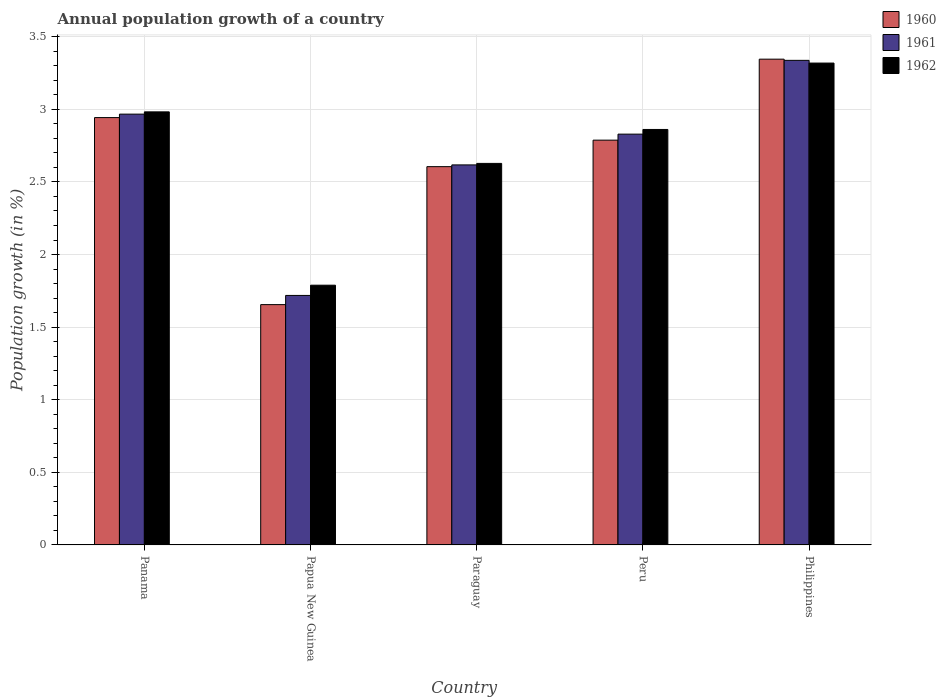How many different coloured bars are there?
Make the answer very short. 3. Are the number of bars per tick equal to the number of legend labels?
Provide a short and direct response. Yes. Are the number of bars on each tick of the X-axis equal?
Provide a succinct answer. Yes. How many bars are there on the 5th tick from the right?
Your answer should be very brief. 3. What is the label of the 4th group of bars from the left?
Provide a succinct answer. Peru. In how many cases, is the number of bars for a given country not equal to the number of legend labels?
Your answer should be very brief. 0. What is the annual population growth in 1962 in Panama?
Make the answer very short. 2.98. Across all countries, what is the maximum annual population growth in 1960?
Ensure brevity in your answer.  3.35. Across all countries, what is the minimum annual population growth in 1962?
Keep it short and to the point. 1.79. In which country was the annual population growth in 1960 minimum?
Provide a succinct answer. Papua New Guinea. What is the total annual population growth in 1960 in the graph?
Make the answer very short. 13.34. What is the difference between the annual population growth in 1962 in Papua New Guinea and that in Peru?
Keep it short and to the point. -1.07. What is the difference between the annual population growth in 1962 in Philippines and the annual population growth in 1960 in Peru?
Keep it short and to the point. 0.53. What is the average annual population growth in 1960 per country?
Provide a succinct answer. 2.67. What is the difference between the annual population growth of/in 1962 and annual population growth of/in 1960 in Philippines?
Offer a terse response. -0.03. What is the ratio of the annual population growth in 1960 in Panama to that in Papua New Guinea?
Your response must be concise. 1.78. Is the annual population growth in 1960 in Papua New Guinea less than that in Philippines?
Provide a succinct answer. Yes. Is the difference between the annual population growth in 1962 in Panama and Peru greater than the difference between the annual population growth in 1960 in Panama and Peru?
Provide a succinct answer. No. What is the difference between the highest and the second highest annual population growth in 1962?
Provide a short and direct response. -0.34. What is the difference between the highest and the lowest annual population growth in 1961?
Ensure brevity in your answer.  1.62. Is the sum of the annual population growth in 1962 in Papua New Guinea and Paraguay greater than the maximum annual population growth in 1960 across all countries?
Provide a succinct answer. Yes. Is it the case that in every country, the sum of the annual population growth in 1960 and annual population growth in 1962 is greater than the annual population growth in 1961?
Your response must be concise. Yes. What is the difference between two consecutive major ticks on the Y-axis?
Offer a terse response. 0.5. Are the values on the major ticks of Y-axis written in scientific E-notation?
Offer a very short reply. No. Does the graph contain grids?
Offer a very short reply. Yes. How are the legend labels stacked?
Your response must be concise. Vertical. What is the title of the graph?
Keep it short and to the point. Annual population growth of a country. Does "1960" appear as one of the legend labels in the graph?
Your answer should be compact. Yes. What is the label or title of the Y-axis?
Your answer should be very brief. Population growth (in %). What is the Population growth (in %) in 1960 in Panama?
Ensure brevity in your answer.  2.94. What is the Population growth (in %) in 1961 in Panama?
Your answer should be very brief. 2.97. What is the Population growth (in %) in 1962 in Panama?
Your answer should be compact. 2.98. What is the Population growth (in %) in 1960 in Papua New Guinea?
Ensure brevity in your answer.  1.66. What is the Population growth (in %) in 1961 in Papua New Guinea?
Provide a succinct answer. 1.72. What is the Population growth (in %) of 1962 in Papua New Guinea?
Provide a succinct answer. 1.79. What is the Population growth (in %) in 1960 in Paraguay?
Provide a succinct answer. 2.61. What is the Population growth (in %) of 1961 in Paraguay?
Provide a succinct answer. 2.62. What is the Population growth (in %) of 1962 in Paraguay?
Keep it short and to the point. 2.63. What is the Population growth (in %) in 1960 in Peru?
Ensure brevity in your answer.  2.79. What is the Population growth (in %) in 1961 in Peru?
Provide a short and direct response. 2.83. What is the Population growth (in %) in 1962 in Peru?
Keep it short and to the point. 2.86. What is the Population growth (in %) of 1960 in Philippines?
Ensure brevity in your answer.  3.35. What is the Population growth (in %) in 1961 in Philippines?
Give a very brief answer. 3.34. What is the Population growth (in %) in 1962 in Philippines?
Your answer should be compact. 3.32. Across all countries, what is the maximum Population growth (in %) of 1960?
Ensure brevity in your answer.  3.35. Across all countries, what is the maximum Population growth (in %) in 1961?
Provide a short and direct response. 3.34. Across all countries, what is the maximum Population growth (in %) of 1962?
Provide a succinct answer. 3.32. Across all countries, what is the minimum Population growth (in %) of 1960?
Provide a succinct answer. 1.66. Across all countries, what is the minimum Population growth (in %) of 1961?
Your response must be concise. 1.72. Across all countries, what is the minimum Population growth (in %) in 1962?
Offer a terse response. 1.79. What is the total Population growth (in %) of 1960 in the graph?
Your answer should be very brief. 13.34. What is the total Population growth (in %) in 1961 in the graph?
Make the answer very short. 13.47. What is the total Population growth (in %) of 1962 in the graph?
Ensure brevity in your answer.  13.58. What is the difference between the Population growth (in %) in 1960 in Panama and that in Papua New Guinea?
Your response must be concise. 1.29. What is the difference between the Population growth (in %) of 1961 in Panama and that in Papua New Guinea?
Make the answer very short. 1.25. What is the difference between the Population growth (in %) of 1962 in Panama and that in Papua New Guinea?
Your response must be concise. 1.19. What is the difference between the Population growth (in %) in 1960 in Panama and that in Paraguay?
Provide a succinct answer. 0.34. What is the difference between the Population growth (in %) of 1961 in Panama and that in Paraguay?
Your answer should be very brief. 0.35. What is the difference between the Population growth (in %) in 1962 in Panama and that in Paraguay?
Provide a short and direct response. 0.35. What is the difference between the Population growth (in %) of 1960 in Panama and that in Peru?
Keep it short and to the point. 0.16. What is the difference between the Population growth (in %) of 1961 in Panama and that in Peru?
Your answer should be compact. 0.14. What is the difference between the Population growth (in %) of 1962 in Panama and that in Peru?
Offer a terse response. 0.12. What is the difference between the Population growth (in %) of 1960 in Panama and that in Philippines?
Offer a terse response. -0.4. What is the difference between the Population growth (in %) in 1961 in Panama and that in Philippines?
Give a very brief answer. -0.37. What is the difference between the Population growth (in %) of 1962 in Panama and that in Philippines?
Provide a short and direct response. -0.34. What is the difference between the Population growth (in %) in 1960 in Papua New Guinea and that in Paraguay?
Provide a short and direct response. -0.95. What is the difference between the Population growth (in %) of 1961 in Papua New Guinea and that in Paraguay?
Your answer should be compact. -0.9. What is the difference between the Population growth (in %) of 1962 in Papua New Guinea and that in Paraguay?
Provide a succinct answer. -0.84. What is the difference between the Population growth (in %) of 1960 in Papua New Guinea and that in Peru?
Your answer should be compact. -1.13. What is the difference between the Population growth (in %) in 1961 in Papua New Guinea and that in Peru?
Your answer should be very brief. -1.11. What is the difference between the Population growth (in %) in 1962 in Papua New Guinea and that in Peru?
Provide a succinct answer. -1.07. What is the difference between the Population growth (in %) of 1960 in Papua New Guinea and that in Philippines?
Offer a very short reply. -1.69. What is the difference between the Population growth (in %) in 1961 in Papua New Guinea and that in Philippines?
Keep it short and to the point. -1.62. What is the difference between the Population growth (in %) of 1962 in Papua New Guinea and that in Philippines?
Your response must be concise. -1.53. What is the difference between the Population growth (in %) of 1960 in Paraguay and that in Peru?
Your response must be concise. -0.18. What is the difference between the Population growth (in %) of 1961 in Paraguay and that in Peru?
Provide a short and direct response. -0.21. What is the difference between the Population growth (in %) in 1962 in Paraguay and that in Peru?
Offer a very short reply. -0.23. What is the difference between the Population growth (in %) in 1960 in Paraguay and that in Philippines?
Provide a short and direct response. -0.74. What is the difference between the Population growth (in %) of 1961 in Paraguay and that in Philippines?
Ensure brevity in your answer.  -0.72. What is the difference between the Population growth (in %) in 1962 in Paraguay and that in Philippines?
Provide a short and direct response. -0.69. What is the difference between the Population growth (in %) in 1960 in Peru and that in Philippines?
Make the answer very short. -0.56. What is the difference between the Population growth (in %) of 1961 in Peru and that in Philippines?
Ensure brevity in your answer.  -0.51. What is the difference between the Population growth (in %) of 1962 in Peru and that in Philippines?
Your answer should be very brief. -0.46. What is the difference between the Population growth (in %) of 1960 in Panama and the Population growth (in %) of 1961 in Papua New Guinea?
Make the answer very short. 1.22. What is the difference between the Population growth (in %) in 1960 in Panama and the Population growth (in %) in 1962 in Papua New Guinea?
Provide a short and direct response. 1.15. What is the difference between the Population growth (in %) of 1961 in Panama and the Population growth (in %) of 1962 in Papua New Guinea?
Provide a succinct answer. 1.18. What is the difference between the Population growth (in %) in 1960 in Panama and the Population growth (in %) in 1961 in Paraguay?
Ensure brevity in your answer.  0.33. What is the difference between the Population growth (in %) of 1960 in Panama and the Population growth (in %) of 1962 in Paraguay?
Provide a short and direct response. 0.32. What is the difference between the Population growth (in %) of 1961 in Panama and the Population growth (in %) of 1962 in Paraguay?
Ensure brevity in your answer.  0.34. What is the difference between the Population growth (in %) in 1960 in Panama and the Population growth (in %) in 1961 in Peru?
Your answer should be compact. 0.11. What is the difference between the Population growth (in %) of 1960 in Panama and the Population growth (in %) of 1962 in Peru?
Ensure brevity in your answer.  0.08. What is the difference between the Population growth (in %) in 1961 in Panama and the Population growth (in %) in 1962 in Peru?
Your response must be concise. 0.11. What is the difference between the Population growth (in %) in 1960 in Panama and the Population growth (in %) in 1961 in Philippines?
Make the answer very short. -0.39. What is the difference between the Population growth (in %) in 1960 in Panama and the Population growth (in %) in 1962 in Philippines?
Provide a short and direct response. -0.38. What is the difference between the Population growth (in %) of 1961 in Panama and the Population growth (in %) of 1962 in Philippines?
Provide a short and direct response. -0.35. What is the difference between the Population growth (in %) in 1960 in Papua New Guinea and the Population growth (in %) in 1961 in Paraguay?
Give a very brief answer. -0.96. What is the difference between the Population growth (in %) of 1960 in Papua New Guinea and the Population growth (in %) of 1962 in Paraguay?
Keep it short and to the point. -0.97. What is the difference between the Population growth (in %) in 1961 in Papua New Guinea and the Population growth (in %) in 1962 in Paraguay?
Provide a short and direct response. -0.91. What is the difference between the Population growth (in %) in 1960 in Papua New Guinea and the Population growth (in %) in 1961 in Peru?
Keep it short and to the point. -1.17. What is the difference between the Population growth (in %) of 1960 in Papua New Guinea and the Population growth (in %) of 1962 in Peru?
Make the answer very short. -1.21. What is the difference between the Population growth (in %) in 1961 in Papua New Guinea and the Population growth (in %) in 1962 in Peru?
Make the answer very short. -1.14. What is the difference between the Population growth (in %) in 1960 in Papua New Guinea and the Population growth (in %) in 1961 in Philippines?
Your answer should be compact. -1.68. What is the difference between the Population growth (in %) in 1960 in Papua New Guinea and the Population growth (in %) in 1962 in Philippines?
Your answer should be very brief. -1.66. What is the difference between the Population growth (in %) in 1961 in Papua New Guinea and the Population growth (in %) in 1962 in Philippines?
Provide a succinct answer. -1.6. What is the difference between the Population growth (in %) of 1960 in Paraguay and the Population growth (in %) of 1961 in Peru?
Your answer should be very brief. -0.22. What is the difference between the Population growth (in %) in 1960 in Paraguay and the Population growth (in %) in 1962 in Peru?
Make the answer very short. -0.26. What is the difference between the Population growth (in %) in 1961 in Paraguay and the Population growth (in %) in 1962 in Peru?
Offer a terse response. -0.24. What is the difference between the Population growth (in %) in 1960 in Paraguay and the Population growth (in %) in 1961 in Philippines?
Your response must be concise. -0.73. What is the difference between the Population growth (in %) of 1960 in Paraguay and the Population growth (in %) of 1962 in Philippines?
Provide a short and direct response. -0.71. What is the difference between the Population growth (in %) in 1961 in Paraguay and the Population growth (in %) in 1962 in Philippines?
Provide a short and direct response. -0.7. What is the difference between the Population growth (in %) in 1960 in Peru and the Population growth (in %) in 1961 in Philippines?
Provide a succinct answer. -0.55. What is the difference between the Population growth (in %) of 1960 in Peru and the Population growth (in %) of 1962 in Philippines?
Your answer should be very brief. -0.53. What is the difference between the Population growth (in %) of 1961 in Peru and the Population growth (in %) of 1962 in Philippines?
Your answer should be compact. -0.49. What is the average Population growth (in %) of 1960 per country?
Offer a very short reply. 2.67. What is the average Population growth (in %) in 1961 per country?
Provide a short and direct response. 2.69. What is the average Population growth (in %) of 1962 per country?
Your answer should be compact. 2.72. What is the difference between the Population growth (in %) in 1960 and Population growth (in %) in 1961 in Panama?
Your answer should be very brief. -0.02. What is the difference between the Population growth (in %) in 1960 and Population growth (in %) in 1962 in Panama?
Provide a succinct answer. -0.04. What is the difference between the Population growth (in %) of 1961 and Population growth (in %) of 1962 in Panama?
Ensure brevity in your answer.  -0.02. What is the difference between the Population growth (in %) of 1960 and Population growth (in %) of 1961 in Papua New Guinea?
Ensure brevity in your answer.  -0.06. What is the difference between the Population growth (in %) of 1960 and Population growth (in %) of 1962 in Papua New Guinea?
Your response must be concise. -0.13. What is the difference between the Population growth (in %) in 1961 and Population growth (in %) in 1962 in Papua New Guinea?
Offer a very short reply. -0.07. What is the difference between the Population growth (in %) in 1960 and Population growth (in %) in 1961 in Paraguay?
Offer a terse response. -0.01. What is the difference between the Population growth (in %) of 1960 and Population growth (in %) of 1962 in Paraguay?
Your response must be concise. -0.02. What is the difference between the Population growth (in %) in 1961 and Population growth (in %) in 1962 in Paraguay?
Your response must be concise. -0.01. What is the difference between the Population growth (in %) of 1960 and Population growth (in %) of 1961 in Peru?
Your answer should be compact. -0.04. What is the difference between the Population growth (in %) of 1960 and Population growth (in %) of 1962 in Peru?
Your answer should be compact. -0.07. What is the difference between the Population growth (in %) of 1961 and Population growth (in %) of 1962 in Peru?
Your answer should be very brief. -0.03. What is the difference between the Population growth (in %) in 1960 and Population growth (in %) in 1961 in Philippines?
Keep it short and to the point. 0.01. What is the difference between the Population growth (in %) of 1960 and Population growth (in %) of 1962 in Philippines?
Provide a short and direct response. 0.03. What is the difference between the Population growth (in %) of 1961 and Population growth (in %) of 1962 in Philippines?
Keep it short and to the point. 0.02. What is the ratio of the Population growth (in %) in 1960 in Panama to that in Papua New Guinea?
Your response must be concise. 1.78. What is the ratio of the Population growth (in %) in 1961 in Panama to that in Papua New Guinea?
Provide a short and direct response. 1.73. What is the ratio of the Population growth (in %) in 1962 in Panama to that in Papua New Guinea?
Your answer should be compact. 1.67. What is the ratio of the Population growth (in %) of 1960 in Panama to that in Paraguay?
Ensure brevity in your answer.  1.13. What is the ratio of the Population growth (in %) of 1961 in Panama to that in Paraguay?
Offer a very short reply. 1.13. What is the ratio of the Population growth (in %) in 1962 in Panama to that in Paraguay?
Provide a short and direct response. 1.14. What is the ratio of the Population growth (in %) in 1960 in Panama to that in Peru?
Your answer should be compact. 1.06. What is the ratio of the Population growth (in %) of 1961 in Panama to that in Peru?
Your response must be concise. 1.05. What is the ratio of the Population growth (in %) of 1962 in Panama to that in Peru?
Offer a very short reply. 1.04. What is the ratio of the Population growth (in %) in 1960 in Panama to that in Philippines?
Give a very brief answer. 0.88. What is the ratio of the Population growth (in %) in 1961 in Panama to that in Philippines?
Keep it short and to the point. 0.89. What is the ratio of the Population growth (in %) in 1962 in Panama to that in Philippines?
Ensure brevity in your answer.  0.9. What is the ratio of the Population growth (in %) of 1960 in Papua New Guinea to that in Paraguay?
Your answer should be compact. 0.64. What is the ratio of the Population growth (in %) of 1961 in Papua New Guinea to that in Paraguay?
Ensure brevity in your answer.  0.66. What is the ratio of the Population growth (in %) of 1962 in Papua New Guinea to that in Paraguay?
Your answer should be compact. 0.68. What is the ratio of the Population growth (in %) in 1960 in Papua New Guinea to that in Peru?
Give a very brief answer. 0.59. What is the ratio of the Population growth (in %) of 1961 in Papua New Guinea to that in Peru?
Ensure brevity in your answer.  0.61. What is the ratio of the Population growth (in %) in 1962 in Papua New Guinea to that in Peru?
Offer a terse response. 0.63. What is the ratio of the Population growth (in %) in 1960 in Papua New Guinea to that in Philippines?
Ensure brevity in your answer.  0.49. What is the ratio of the Population growth (in %) of 1961 in Papua New Guinea to that in Philippines?
Provide a short and direct response. 0.51. What is the ratio of the Population growth (in %) of 1962 in Papua New Guinea to that in Philippines?
Provide a short and direct response. 0.54. What is the ratio of the Population growth (in %) of 1960 in Paraguay to that in Peru?
Offer a very short reply. 0.93. What is the ratio of the Population growth (in %) of 1961 in Paraguay to that in Peru?
Provide a succinct answer. 0.93. What is the ratio of the Population growth (in %) of 1962 in Paraguay to that in Peru?
Provide a short and direct response. 0.92. What is the ratio of the Population growth (in %) in 1960 in Paraguay to that in Philippines?
Make the answer very short. 0.78. What is the ratio of the Population growth (in %) of 1961 in Paraguay to that in Philippines?
Offer a very short reply. 0.78. What is the ratio of the Population growth (in %) in 1962 in Paraguay to that in Philippines?
Make the answer very short. 0.79. What is the ratio of the Population growth (in %) of 1960 in Peru to that in Philippines?
Ensure brevity in your answer.  0.83. What is the ratio of the Population growth (in %) in 1961 in Peru to that in Philippines?
Your answer should be very brief. 0.85. What is the ratio of the Population growth (in %) of 1962 in Peru to that in Philippines?
Offer a terse response. 0.86. What is the difference between the highest and the second highest Population growth (in %) of 1960?
Provide a succinct answer. 0.4. What is the difference between the highest and the second highest Population growth (in %) of 1961?
Offer a terse response. 0.37. What is the difference between the highest and the second highest Population growth (in %) in 1962?
Offer a terse response. 0.34. What is the difference between the highest and the lowest Population growth (in %) of 1960?
Offer a very short reply. 1.69. What is the difference between the highest and the lowest Population growth (in %) in 1961?
Offer a very short reply. 1.62. What is the difference between the highest and the lowest Population growth (in %) in 1962?
Keep it short and to the point. 1.53. 